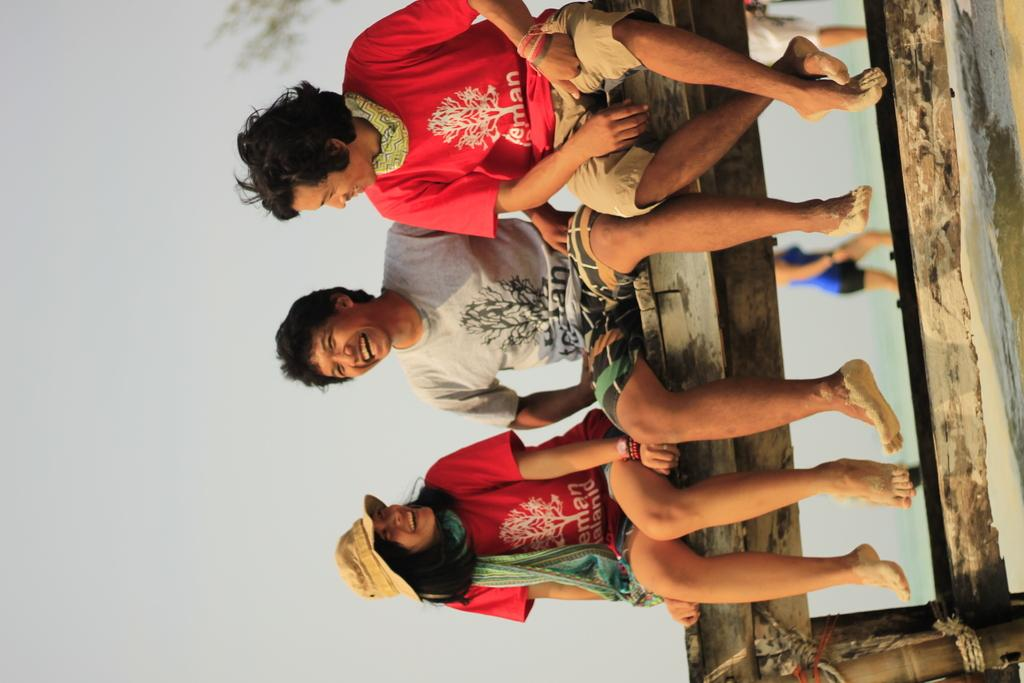How many people are sitting on the wooden bench in the image? There are three people sitting on a wooden bench in the image. What can be seen in the background of the image? There is a woman walking on a path in the background, and the sky is visible. What type of wine is being served on the floor in the image? There is no wine or floor present in the image; it only features three people sitting on a wooden bench and a woman walking on a path in the background. 